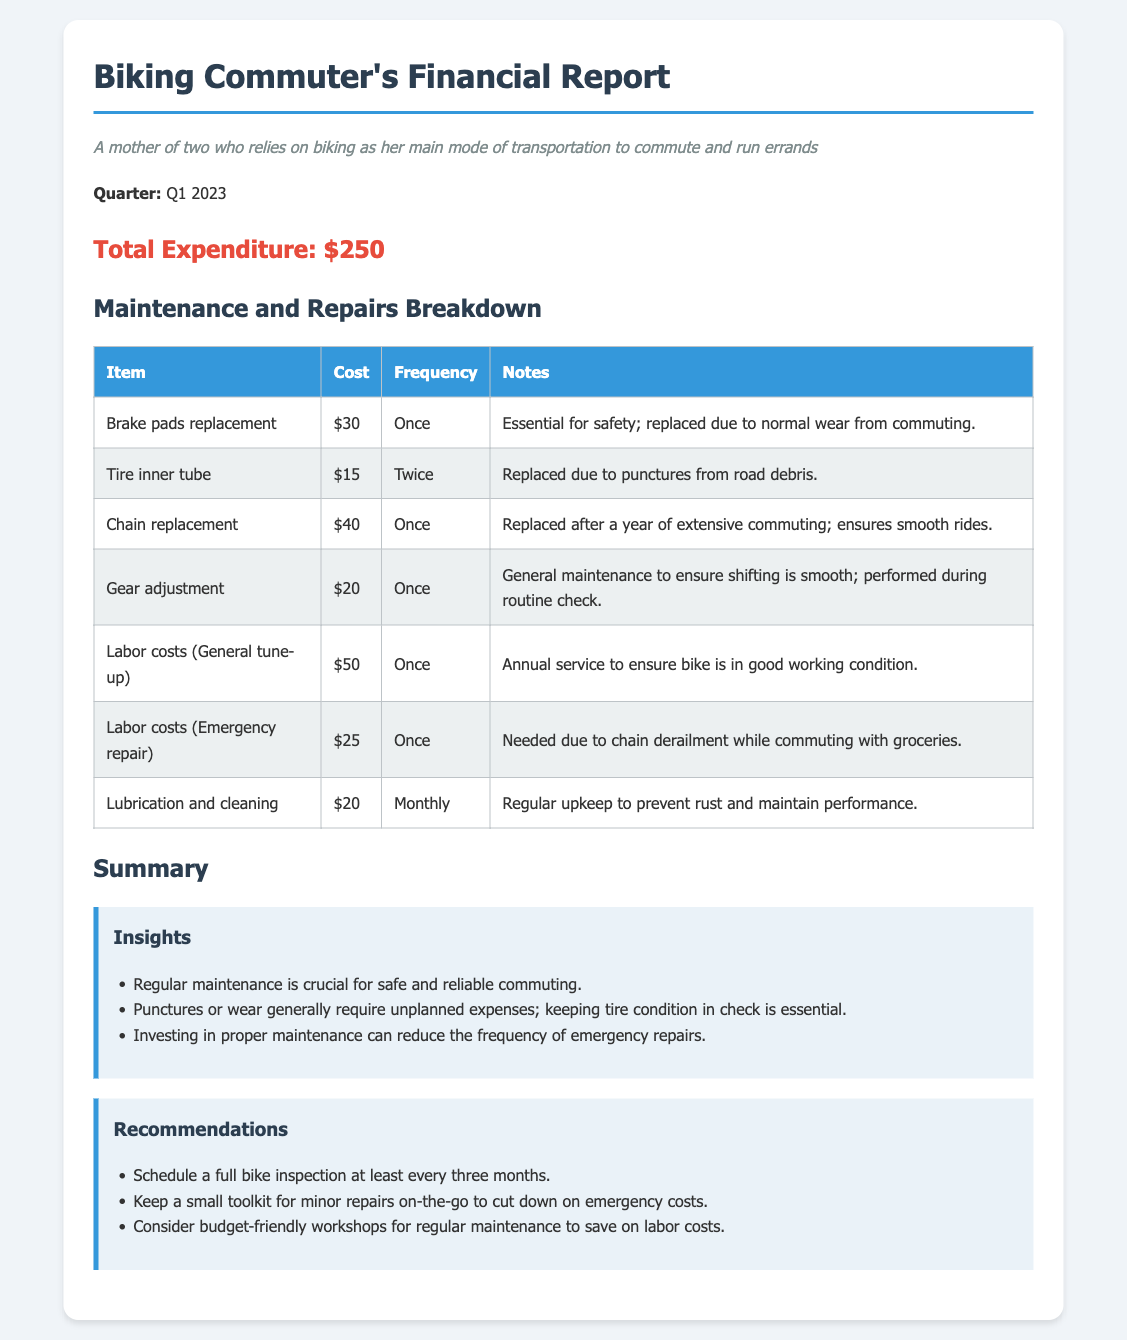What is the total expenditure? The total expenditure is stated at the beginning of the report as a single amount, which is $250.
Answer: $250 How many times were the tire inner tubes replaced? The report specifies the frequency of tire inner tube replacements as twice.
Answer: Twice What is the cost for labor during the general tune-up? The cost for labor during the general tune-up is provided in the maintenance and repairs breakdown section, which is $50.
Answer: $50 Which part was replaced due to a chain derailment? The emergency repair was needed due to chain derailment, as stated in the notes for the labor costs section.
Answer: Chain How often is lubrication and cleaning performed? The frequency of lubrication and cleaning is listed as monthly.
Answer: Monthly What are the recommended intervals for a full bike inspection? The recommendations section states to schedule a full bike inspection at least every three months.
Answer: Every three months What was the cost of brake pads replacement? The cost for brake pads replacement is listed in the breakdown as $30.
Answer: $30 How much was spent on chain replacement? The specific expenditure for chain replacement is mentioned in the report, which is $40.
Answer: $40 What is one benefit of regular maintenance mentioned in the insights? The insights section states that regular maintenance is crucial for safe and reliable commuting.
Answer: Safe and reliable commuting 